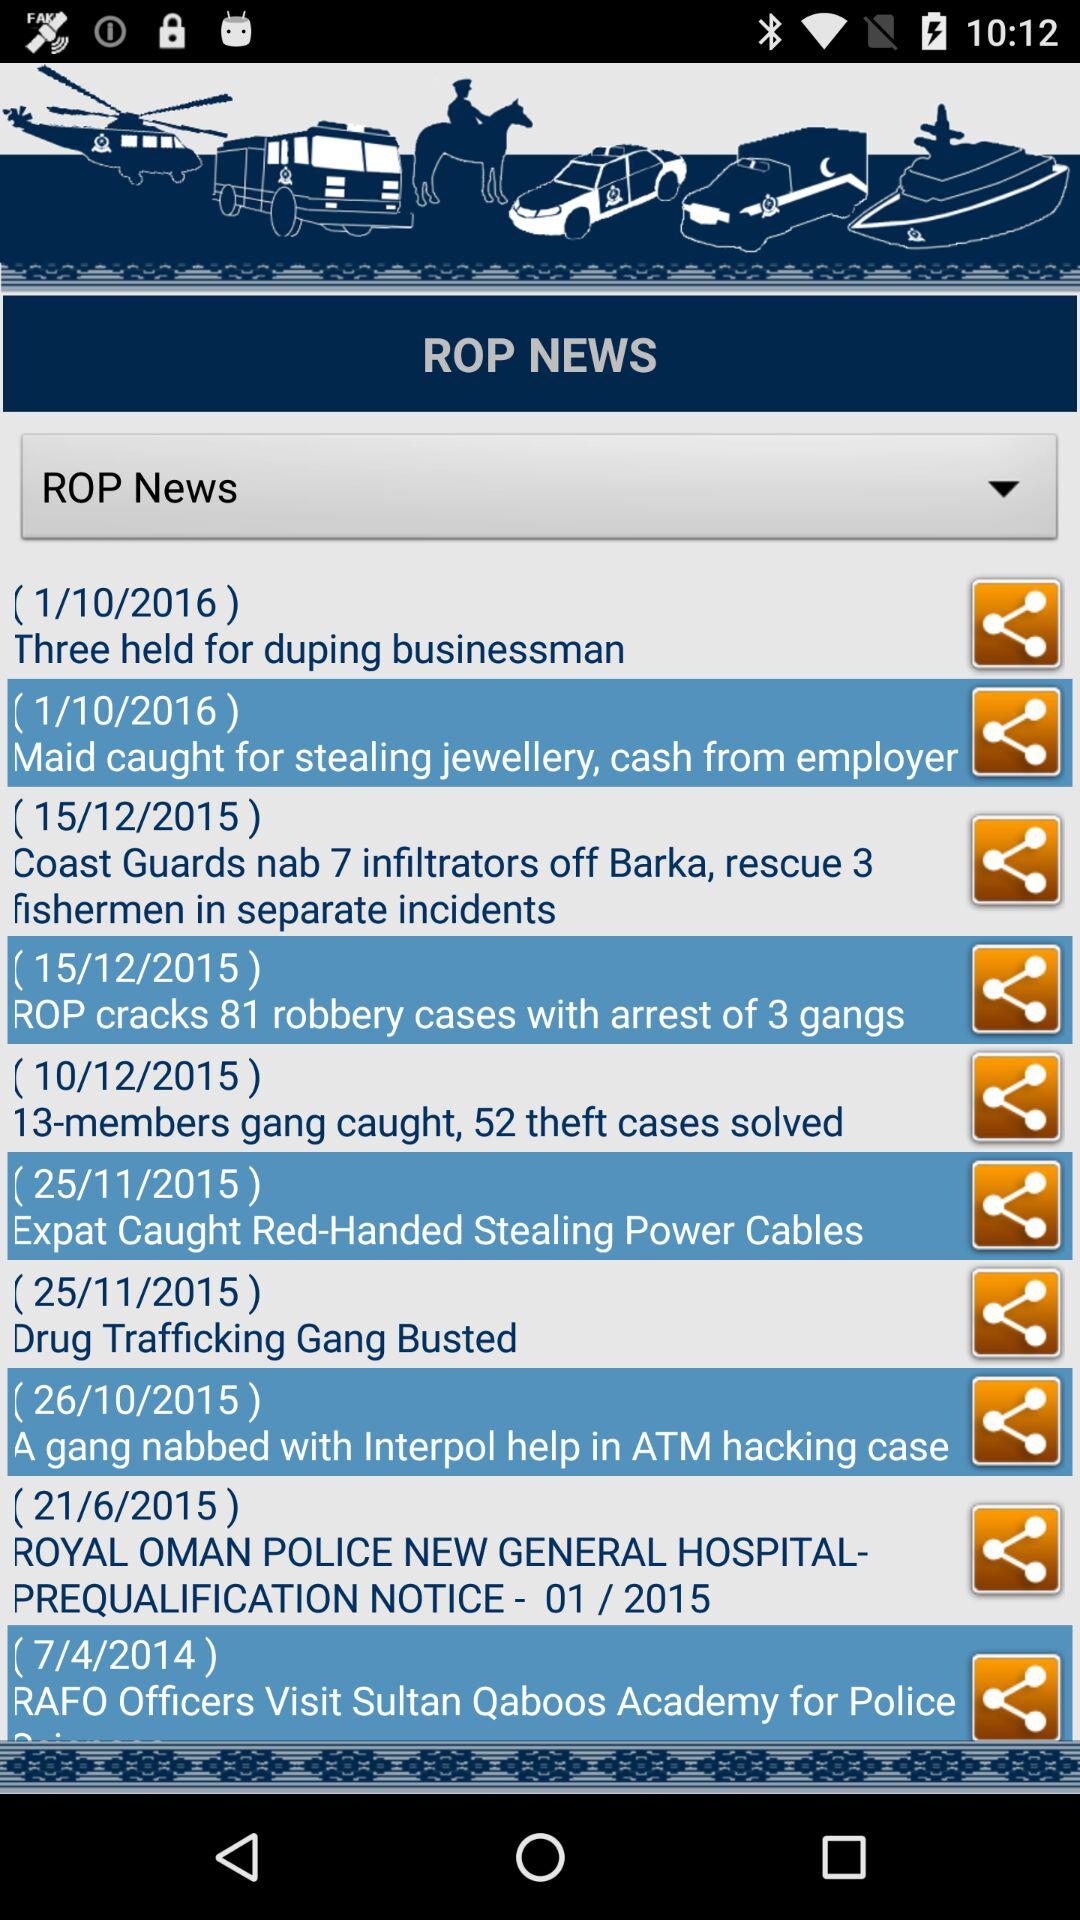What is the app name? The app name is "ROP NEWS". 